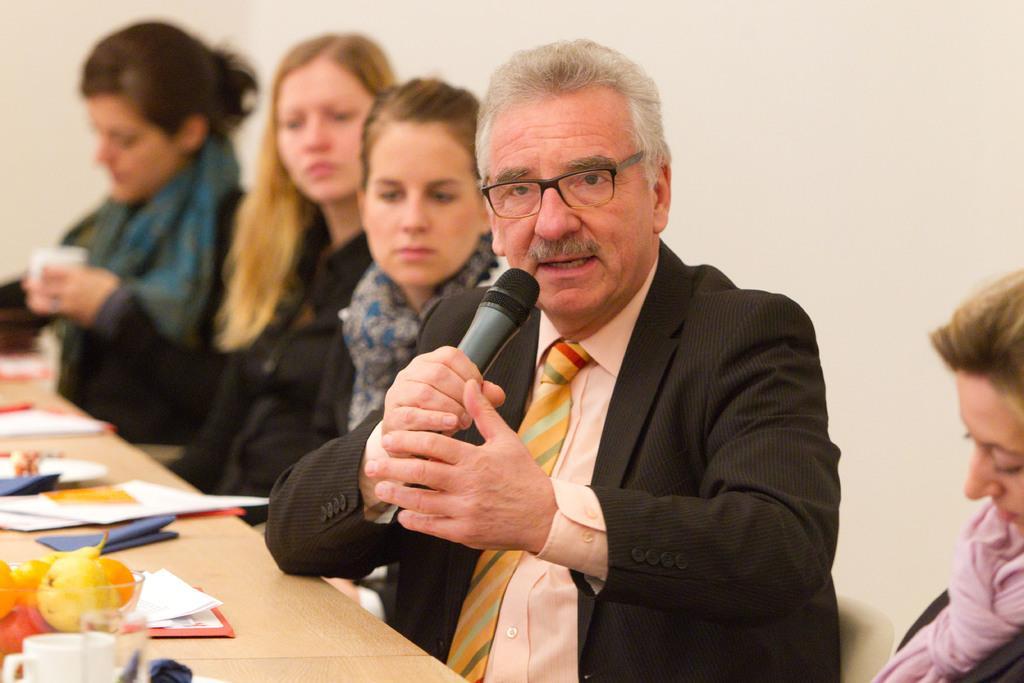In one or two sentences, can you explain what this image depicts? This picture describes about group of people, in the middle of the image we can see a man, he is holding a microphone, in front of him we can find few papers, fruits, cup and other things on the table. 